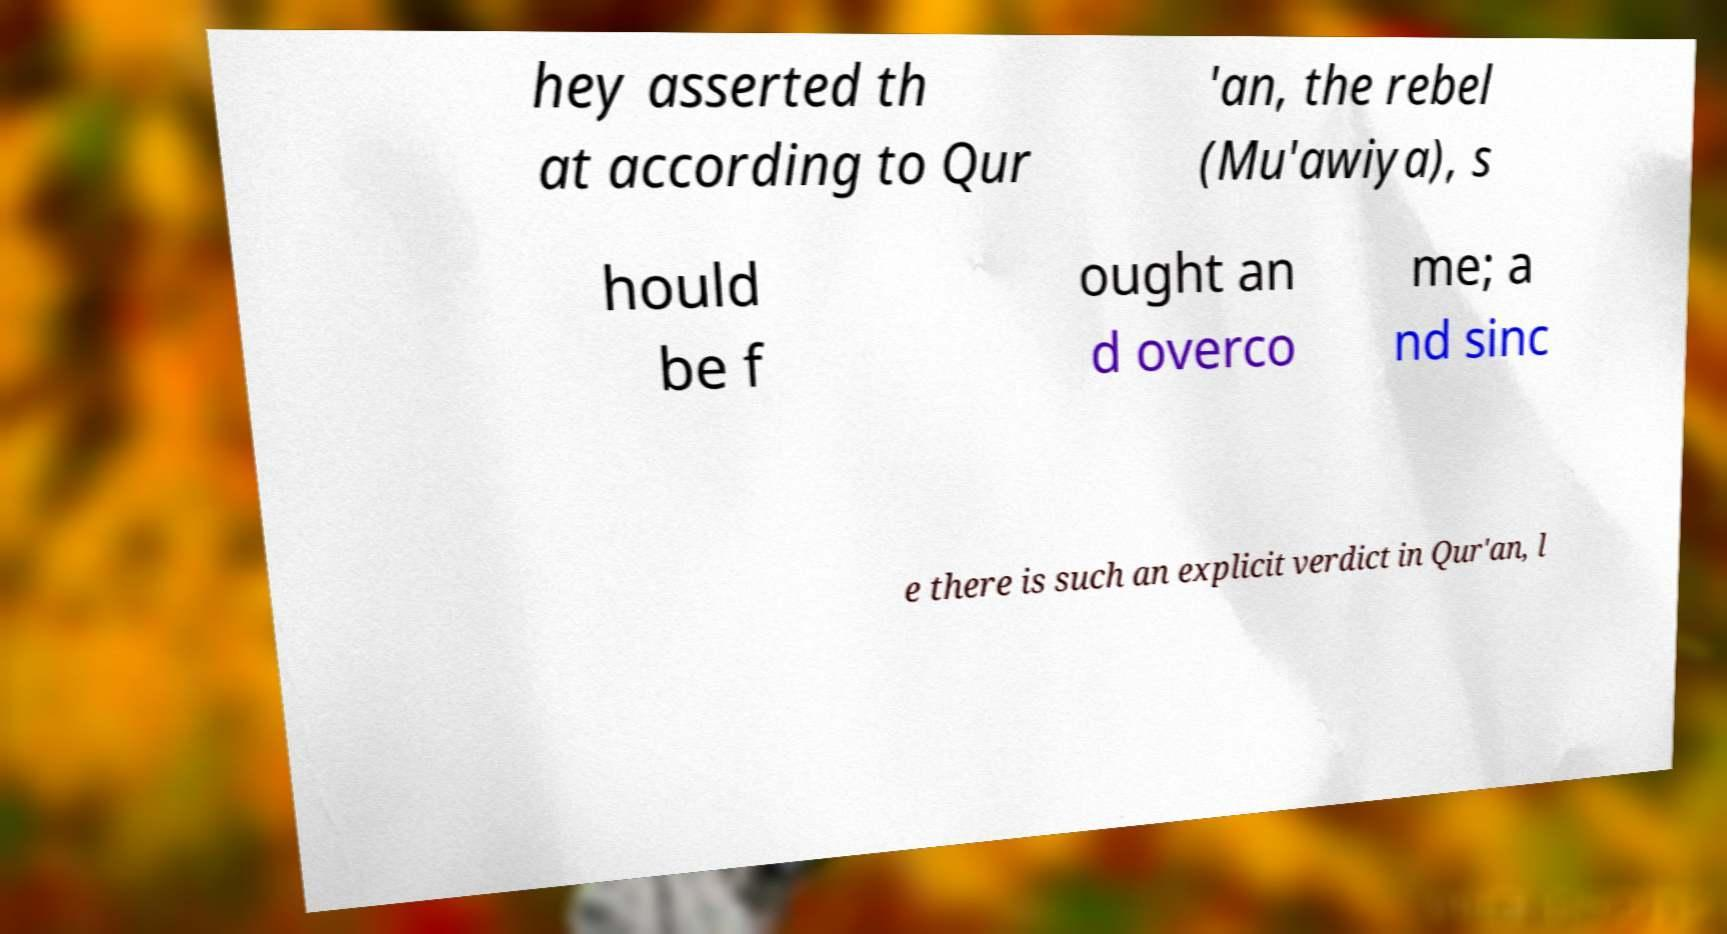I need the written content from this picture converted into text. Can you do that? hey asserted th at according to Qur 'an, the rebel (Mu'awiya), s hould be f ought an d overco me; a nd sinc e there is such an explicit verdict in Qur'an, l 